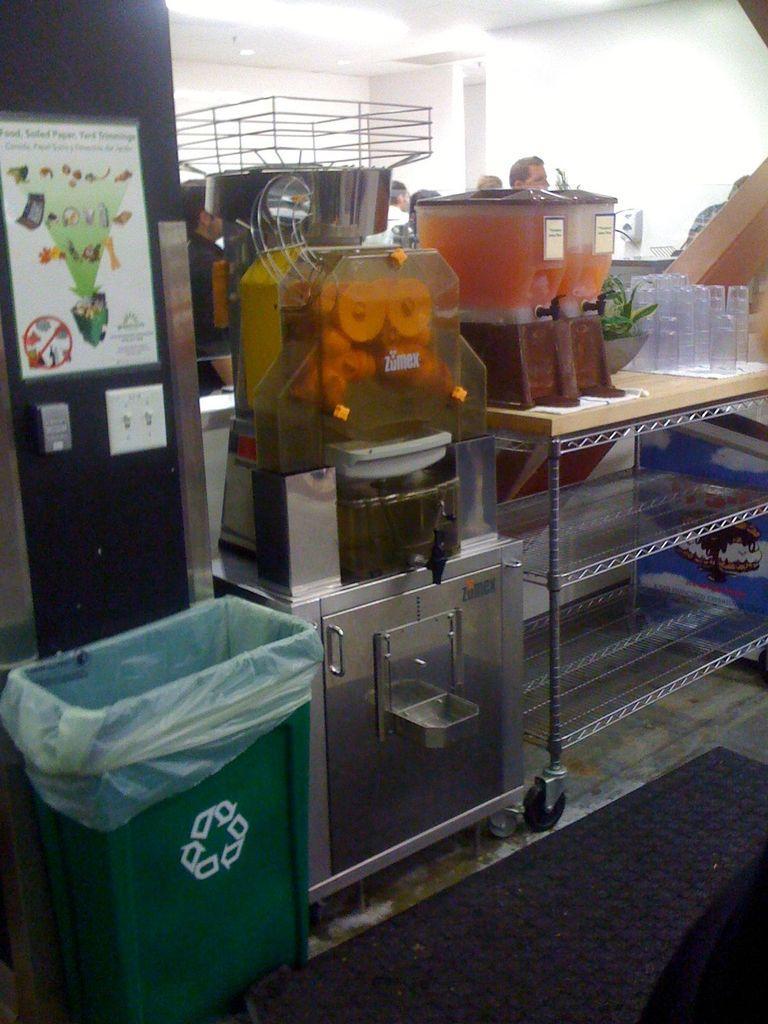Describe this image in one or two sentences. On the background we can see wall and few persons. Here on the table we can see glasses, juice containers, a machine, poster over a wall. This is a trash can, This is a floor. 